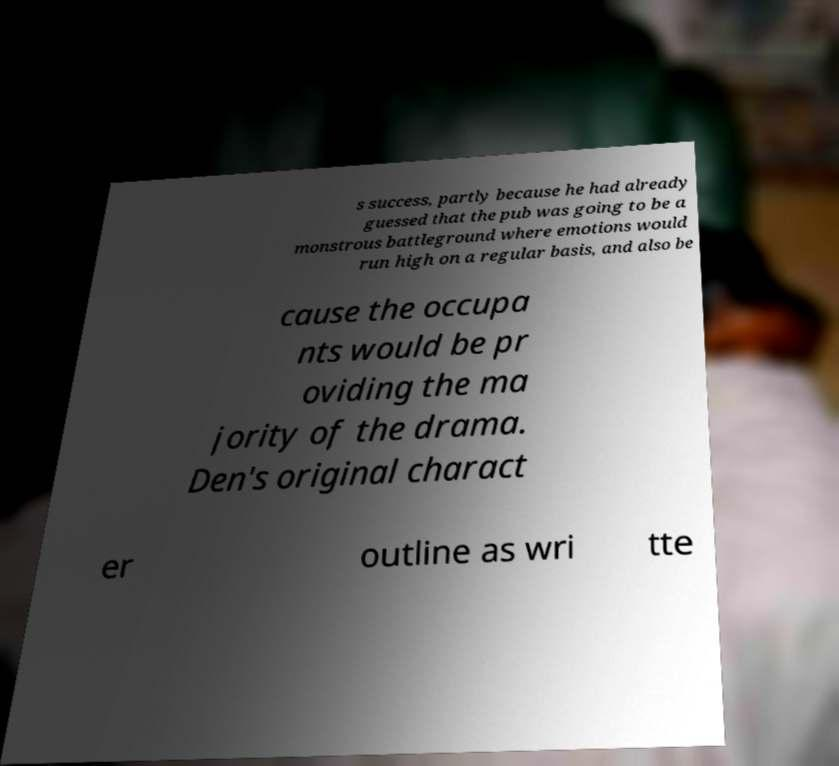For documentation purposes, I need the text within this image transcribed. Could you provide that? s success, partly because he had already guessed that the pub was going to be a monstrous battleground where emotions would run high on a regular basis, and also be cause the occupa nts would be pr oviding the ma jority of the drama. Den's original charact er outline as wri tte 